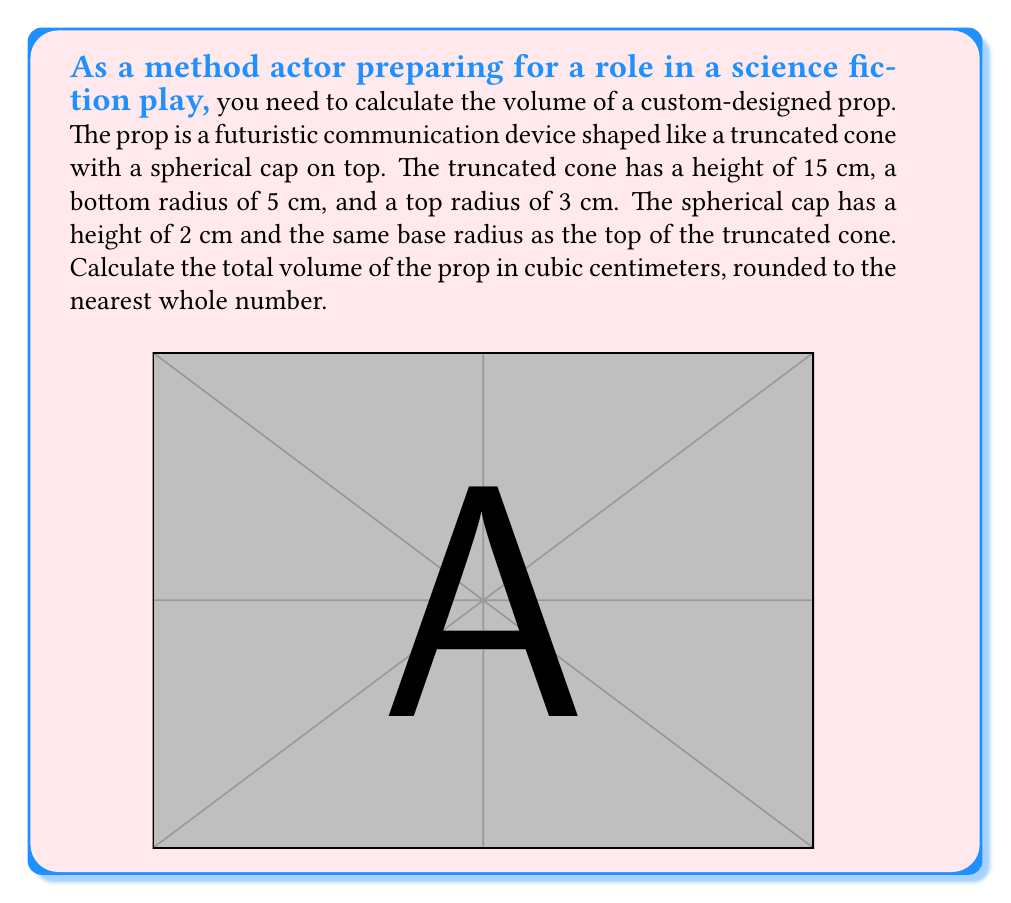Give your solution to this math problem. To calculate the total volume of the prop, we need to sum the volumes of the truncated cone and the spherical cap.

1. Volume of the truncated cone:
The formula for the volume of a truncated cone is:
$$V_{cone} = \frac{1}{3}\pi h(R^2 + r^2 + Rr)$$
where $h$ is the height, $R$ is the radius of the base, and $r$ is the radius of the top.

Substituting the values:
$$V_{cone} = \frac{1}{3}\pi \cdot 15(5^2 + 3^2 + 5 \cdot 3) = 5\pi(25 + 9 + 15) = 245\pi \approx 769.69 \text{ cm}^3$$

2. Volume of the spherical cap:
The formula for the volume of a spherical cap is:
$$V_{cap} = \frac{1}{3}\pi h^2(3r - h)$$
where $h$ is the height of the cap and $r$ is the radius of the base.

To find the radius of the sphere, we use the formula:
$$R = \frac{r^2 + h^2}{2h}$$

Substituting values:
$$R = \frac{3^2 + 2^2}{2 \cdot 2} = \frac{13}{4} = 3.25 \text{ cm}$$

Now we can calculate the volume of the spherical cap:
$$V_{cap} = \frac{1}{3}\pi \cdot 2^2(3 \cdot 3.25 - 2) = \frac{4\pi}{3}(9.75 - 2) = \frac{31\pi}{3} \approx 32.47 \text{ cm}^3$$

3. Total volume:
$$V_{total} = V_{cone} + V_{cap} = 769.69 + 32.47 = 802.16 \text{ cm}^3$$

Rounding to the nearest whole number:
$$V_{total} \approx 802 \text{ cm}^3$$
Answer: 802 cm³ 